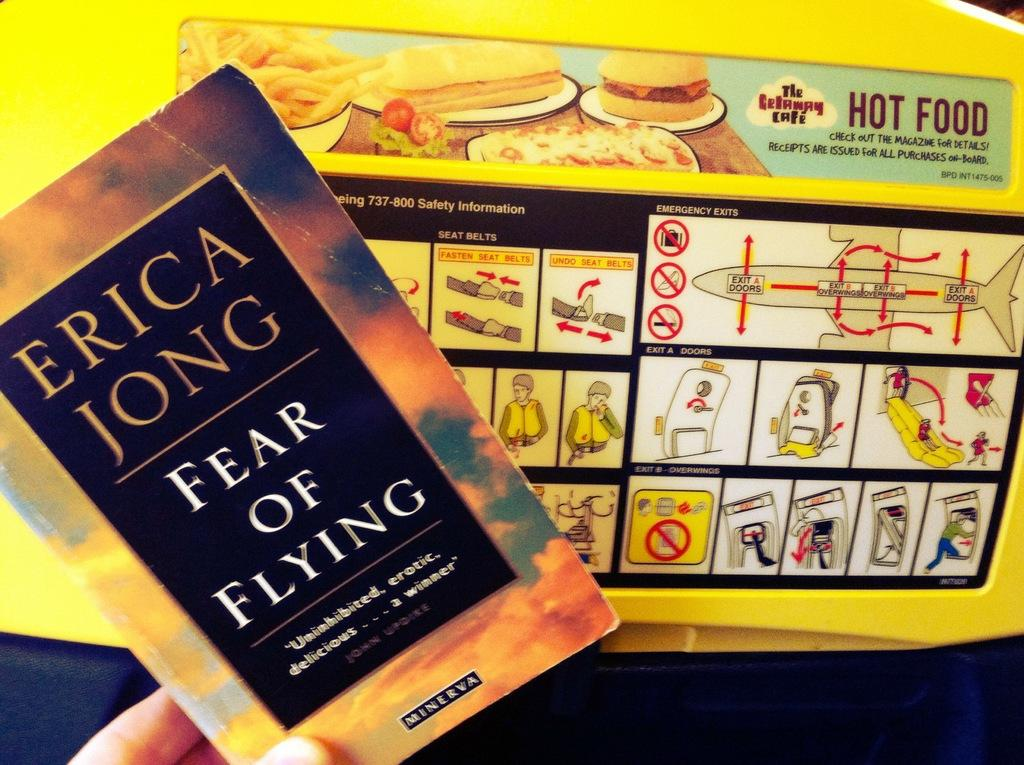<image>
Provide a brief description of the given image. A hand holding a book called Fear of Flying in front of an aircraft poster. 